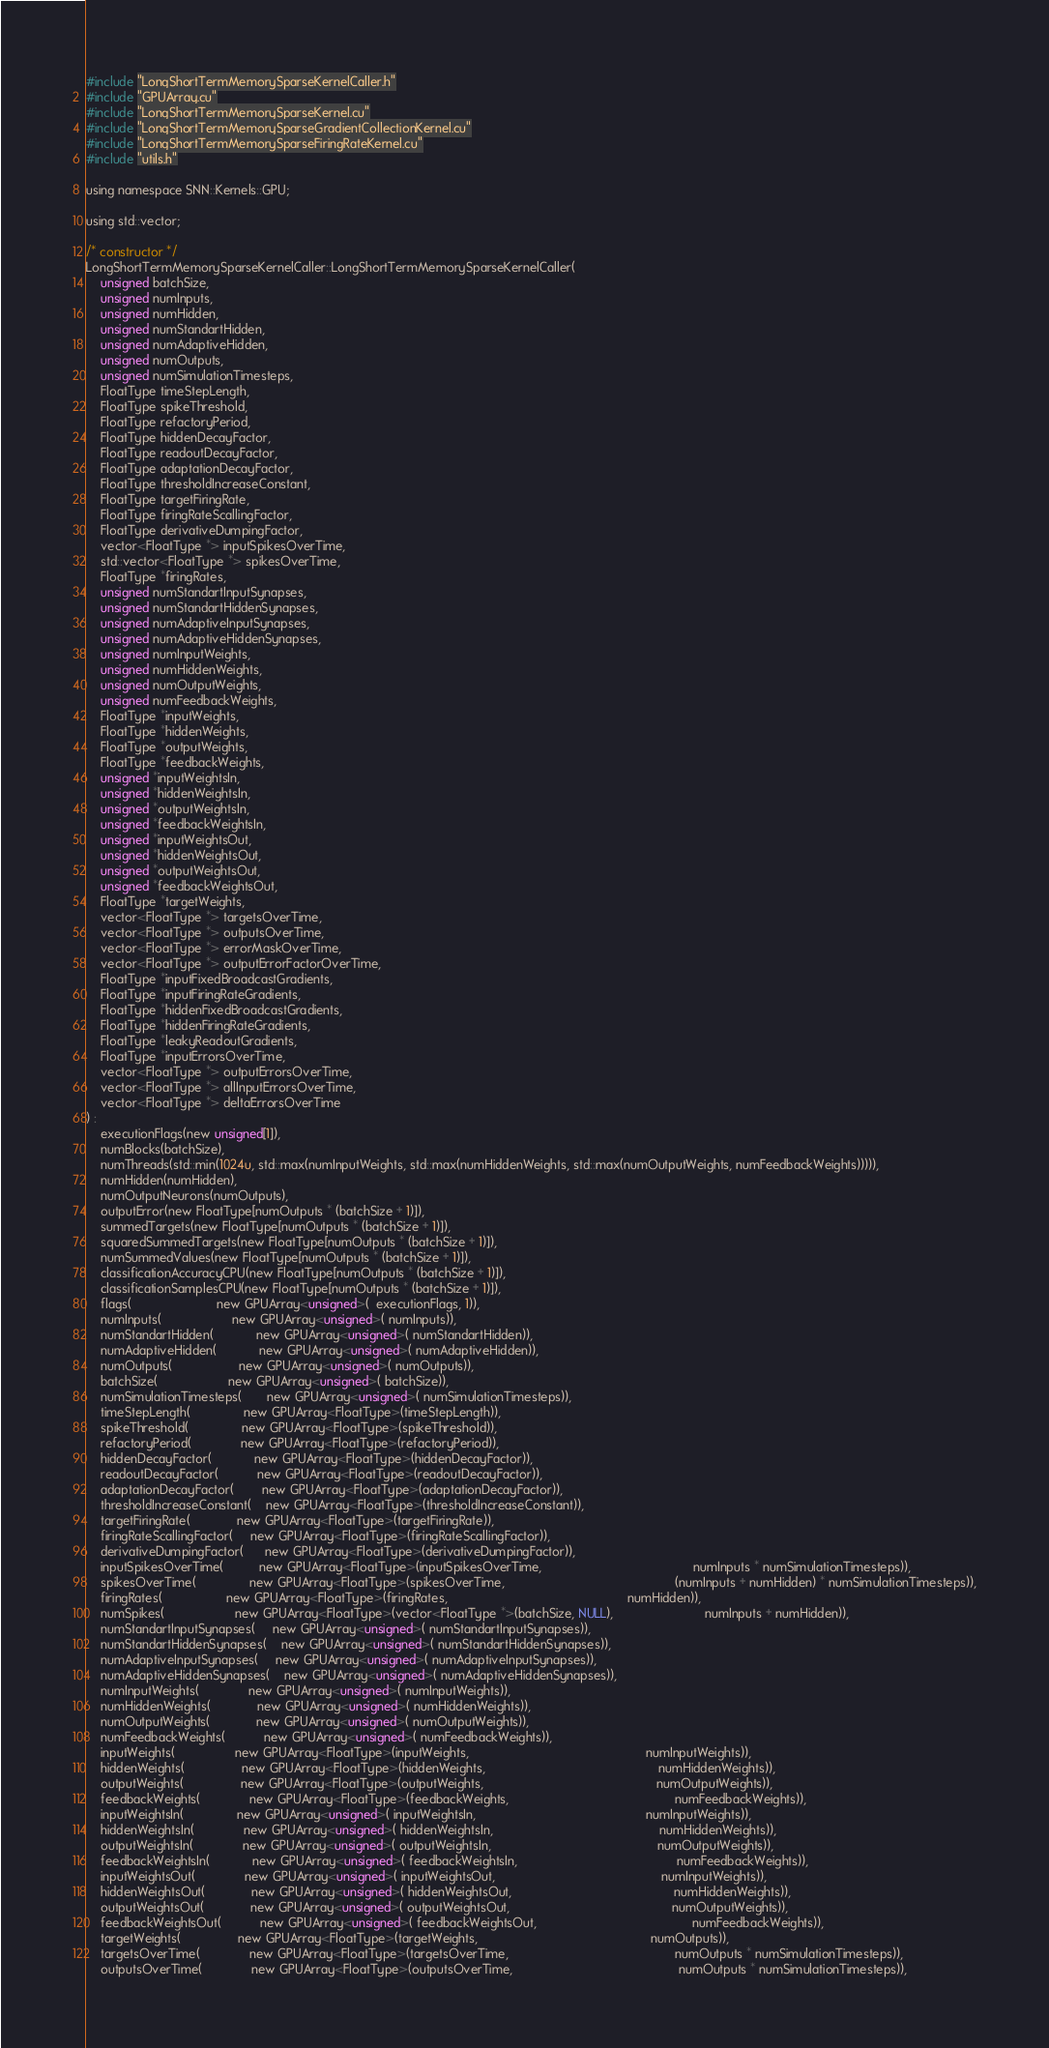Convert code to text. <code><loc_0><loc_0><loc_500><loc_500><_Cuda_>#include "LongShortTermMemorySparseKernelCaller.h"
#include "GPUArray.cu"
#include "LongShortTermMemorySparseKernel.cu"
#include "LongShortTermMemorySparseGradientCollectionKernel.cu"
#include "LongShortTermMemorySparseFiringRateKernel.cu"
#include "utils.h"

using namespace SNN::Kernels::GPU;

using std::vector;

/* constructor */
LongShortTermMemorySparseKernelCaller::LongShortTermMemorySparseKernelCaller(
    unsigned batchSize,
    unsigned numInputs,
    unsigned numHidden,
    unsigned numStandartHidden,
    unsigned numAdaptiveHidden,
    unsigned numOutputs,
    unsigned numSimulationTimesteps,
    FloatType timeStepLength,
    FloatType spikeThreshold,
    FloatType refactoryPeriod,
    FloatType hiddenDecayFactor,
    FloatType readoutDecayFactor,
    FloatType adaptationDecayFactor,
    FloatType thresholdIncreaseConstant,
    FloatType targetFiringRate,
    FloatType firingRateScallingFactor,
    FloatType derivativeDumpingFactor,
    vector<FloatType *> inputSpikesOverTime,
    std::vector<FloatType *> spikesOverTime,
    FloatType *firingRates,
    unsigned numStandartInputSynapses,
    unsigned numStandartHiddenSynapses,
    unsigned numAdaptiveInputSynapses,
    unsigned numAdaptiveHiddenSynapses,
    unsigned numInputWeights,
    unsigned numHiddenWeights,
    unsigned numOutputWeights,
    unsigned numFeedbackWeights,
    FloatType *inputWeights,
    FloatType *hiddenWeights,
    FloatType *outputWeights,
    FloatType *feedbackWeights,
    unsigned *inputWeightsIn,
    unsigned *hiddenWeightsIn,
    unsigned *outputWeightsIn,
    unsigned *feedbackWeightsIn,
    unsigned *inputWeightsOut,
    unsigned *hiddenWeightsOut,
    unsigned *outputWeightsOut,
    unsigned *feedbackWeightsOut,
    FloatType *targetWeights,
    vector<FloatType *> targetsOverTime,
    vector<FloatType *> outputsOverTime,
    vector<FloatType *> errorMaskOverTime,
    vector<FloatType *> outputErrorFactorOverTime,
    FloatType *inputFixedBroadcastGradients,
    FloatType *inputFiringRateGradients,
    FloatType *hiddenFixedBroadcastGradients,
    FloatType *hiddenFiringRateGradients,
    FloatType *leakyReadoutGradients,
    FloatType *inputErrorsOverTime,
    vector<FloatType *> outputErrorsOverTime,
    vector<FloatType *> allInputErrorsOverTime,
    vector<FloatType *> deltaErrorsOverTime
) :
    executionFlags(new unsigned[1]),
    numBlocks(batchSize),
    numThreads(std::min(1024u, std::max(numInputWeights, std::max(numHiddenWeights, std::max(numOutputWeights, numFeedbackWeights))))),
    numHidden(numHidden),
    numOutputNeurons(numOutputs),
    outputError(new FloatType[numOutputs * (batchSize + 1)]),
    summedTargets(new FloatType[numOutputs * (batchSize + 1)]),
    squaredSummedTargets(new FloatType[numOutputs * (batchSize + 1)]),
    numSummedValues(new FloatType[numOutputs * (batchSize + 1)]),
    classificationAccuracyCPU(new FloatType[numOutputs * (batchSize + 1)]),
    classificationSamplesCPU(new FloatType[numOutputs * (batchSize + 1)]),
    flags(                        new GPUArray<unsigned>(  executionFlags, 1)),
    numInputs(                    new GPUArray<unsigned>( numInputs)),
    numStandartHidden(            new GPUArray<unsigned>( numStandartHidden)),
    numAdaptiveHidden(            new GPUArray<unsigned>( numAdaptiveHidden)),
    numOutputs(                   new GPUArray<unsigned>( numOutputs)),
    batchSize(                    new GPUArray<unsigned>( batchSize)),
    numSimulationTimesteps(       new GPUArray<unsigned>( numSimulationTimesteps)),
    timeStepLength(               new GPUArray<FloatType>(timeStepLength)),
    spikeThreshold(               new GPUArray<FloatType>(spikeThreshold)),
    refactoryPeriod(              new GPUArray<FloatType>(refactoryPeriod)),
    hiddenDecayFactor(            new GPUArray<FloatType>(hiddenDecayFactor)),
    readoutDecayFactor(           new GPUArray<FloatType>(readoutDecayFactor)),
    adaptationDecayFactor(        new GPUArray<FloatType>(adaptationDecayFactor)),
    thresholdIncreaseConstant(    new GPUArray<FloatType>(thresholdIncreaseConstant)),
    targetFiringRate(             new GPUArray<FloatType>(targetFiringRate)),
    firingRateScallingFactor(     new GPUArray<FloatType>(firingRateScallingFactor)),
    derivativeDumpingFactor(      new GPUArray<FloatType>(derivativeDumpingFactor)),
    inputSpikesOverTime(          new GPUArray<FloatType>(inputSpikesOverTime,                                           numInputs * numSimulationTimesteps)),
    spikesOverTime(               new GPUArray<FloatType>(spikesOverTime,                                                (numInputs + numHidden) * numSimulationTimesteps)),
    firingRates(                  new GPUArray<FloatType>(firingRates,                                                   numHidden)),
    numSpikes(                    new GPUArray<FloatType>(vector<FloatType *>(batchSize, NULL),                          numInputs + numHidden)),
    numStandartInputSynapses(     new GPUArray<unsigned>( numStandartInputSynapses)),    
    numStandartHiddenSynapses(    new GPUArray<unsigned>( numStandartHiddenSynapses)),    
    numAdaptiveInputSynapses(     new GPUArray<unsigned>( numAdaptiveInputSynapses)),    
    numAdaptiveHiddenSynapses(    new GPUArray<unsigned>( numAdaptiveHiddenSynapses)),    
    numInputWeights(              new GPUArray<unsigned>( numInputWeights)),    
    numHiddenWeights(             new GPUArray<unsigned>( numHiddenWeights)),    
    numOutputWeights(             new GPUArray<unsigned>( numOutputWeights)),    
    numFeedbackWeights(           new GPUArray<unsigned>( numFeedbackWeights)),    
    inputWeights(                 new GPUArray<FloatType>(inputWeights,                                                  numInputWeights)),
    hiddenWeights(                new GPUArray<FloatType>(hiddenWeights,                                                 numHiddenWeights)),
    outputWeights(                new GPUArray<FloatType>(outputWeights,                                                 numOutputWeights)),
    feedbackWeights(              new GPUArray<FloatType>(feedbackWeights,                                               numFeedbackWeights)),
    inputWeightsIn(               new GPUArray<unsigned>( inputWeightsIn,                                                numInputWeights)),
    hiddenWeightsIn(              new GPUArray<unsigned>( hiddenWeightsIn,                                               numHiddenWeights)),
    outputWeightsIn(              new GPUArray<unsigned>( outputWeightsIn,                                               numOutputWeights)),
    feedbackWeightsIn(            new GPUArray<unsigned>( feedbackWeightsIn,                                             numFeedbackWeights)),
    inputWeightsOut(              new GPUArray<unsigned>( inputWeightsOut,                                               numInputWeights)),
    hiddenWeightsOut(             new GPUArray<unsigned>( hiddenWeightsOut,                                              numHiddenWeights)),
    outputWeightsOut(             new GPUArray<unsigned>( outputWeightsOut,                                              numOutputWeights)),
    feedbackWeightsOut(           new GPUArray<unsigned>( feedbackWeightsOut,                                            numFeedbackWeights)),
    targetWeights(                new GPUArray<FloatType>(targetWeights,                                                 numOutputs)),
    targetsOverTime(              new GPUArray<FloatType>(targetsOverTime,                                               numOutputs * numSimulationTimesteps)),
    outputsOverTime(              new GPUArray<FloatType>(outputsOverTime,                                               numOutputs * numSimulationTimesteps)),</code> 